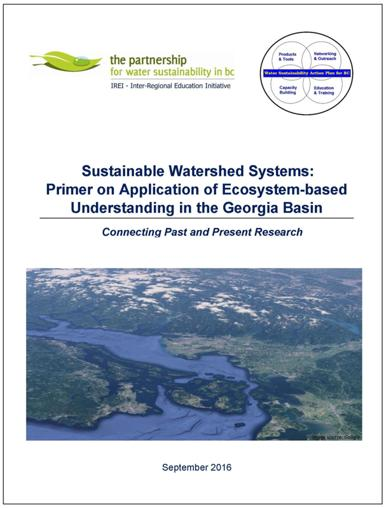Who is responsible for this publication? The publication, as visible in the image, is a collaborative effort put forth by the Partnership for Water Sustainability in BC and the Inter-Regional Education Initiative (IREI). These organizations are likely involved in water conservation and educational efforts within British Columbia, specifically targeting the Georgia Basin watershed. 